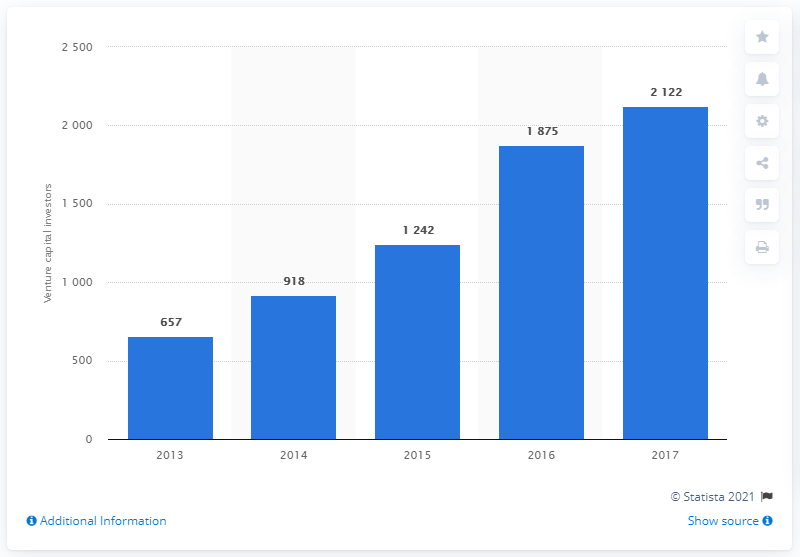Specify some key components in this picture. There were 657 active venture capital investment firms in 2013. 